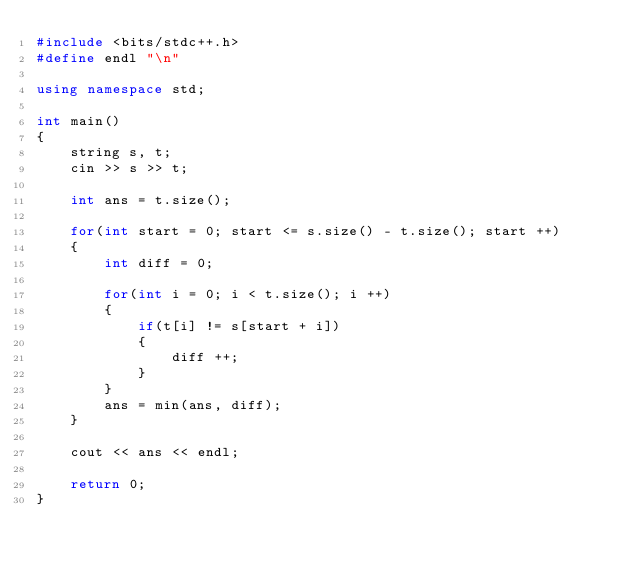<code> <loc_0><loc_0><loc_500><loc_500><_C++_>#include <bits/stdc++.h>
#define endl "\n"

using namespace std;

int main()
{
    string s, t;
    cin >> s >> t;

    int ans = t.size();

    for(int start = 0; start <= s.size() - t.size(); start ++)
    {
        int diff = 0;

        for(int i = 0; i < t.size(); i ++)
        {
            if(t[i] != s[start + i])
            {
                diff ++;
            }
        }
        ans = min(ans, diff);
    }

    cout << ans << endl;

    return 0;
}
</code> 